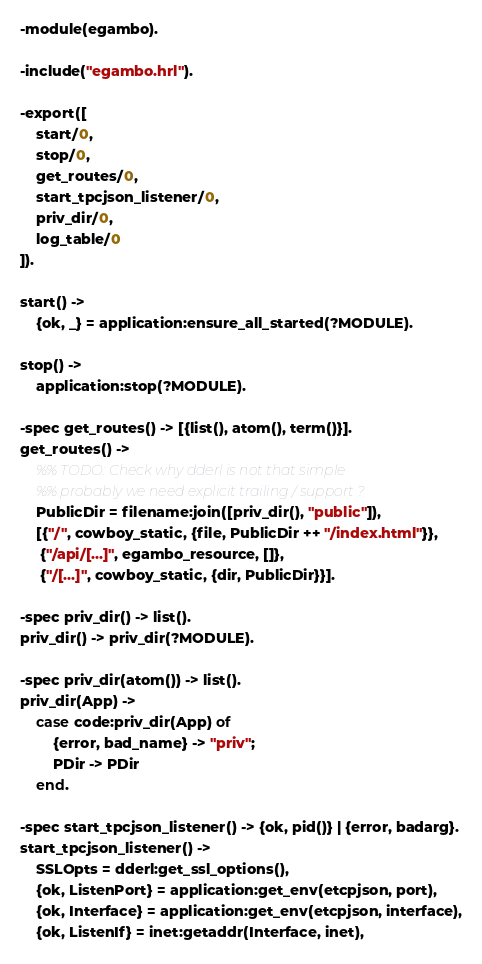Convert code to text. <code><loc_0><loc_0><loc_500><loc_500><_Erlang_>-module(egambo).

-include("egambo.hrl").

-export([
    start/0,
    stop/0,
    get_routes/0,
    start_tpcjson_listener/0,
    priv_dir/0,
    log_table/0
]).

start() ->
    {ok, _} = application:ensure_all_started(?MODULE).

stop() ->
    application:stop(?MODULE).

-spec get_routes() -> [{list(), atom(), term()}].
get_routes() ->
    %% TODO: Check why dderl is not that simple
    %% probably we need explicit trailing / support ?
    PublicDir = filename:join([priv_dir(), "public"]),
    [{"/", cowboy_static, {file, PublicDir ++ "/index.html"}},
     {"/api/[...]", egambo_resource, []},
     {"/[...]", cowboy_static, {dir, PublicDir}}].

-spec priv_dir() -> list().
priv_dir() -> priv_dir(?MODULE).

-spec priv_dir(atom()) -> list().
priv_dir(App) ->
    case code:priv_dir(App) of
        {error, bad_name} -> "priv";
        PDir -> PDir
    end.

-spec start_tpcjson_listener() -> {ok, pid()} | {error, badarg}.
start_tpcjson_listener() ->
    SSLOpts = dderl:get_ssl_options(),
    {ok, ListenPort} = application:get_env(etcpjson, port),
    {ok, Interface} = application:get_env(etcpjson, interface),
    {ok, ListenIf} = inet:getaddr(Interface, inet),</code> 